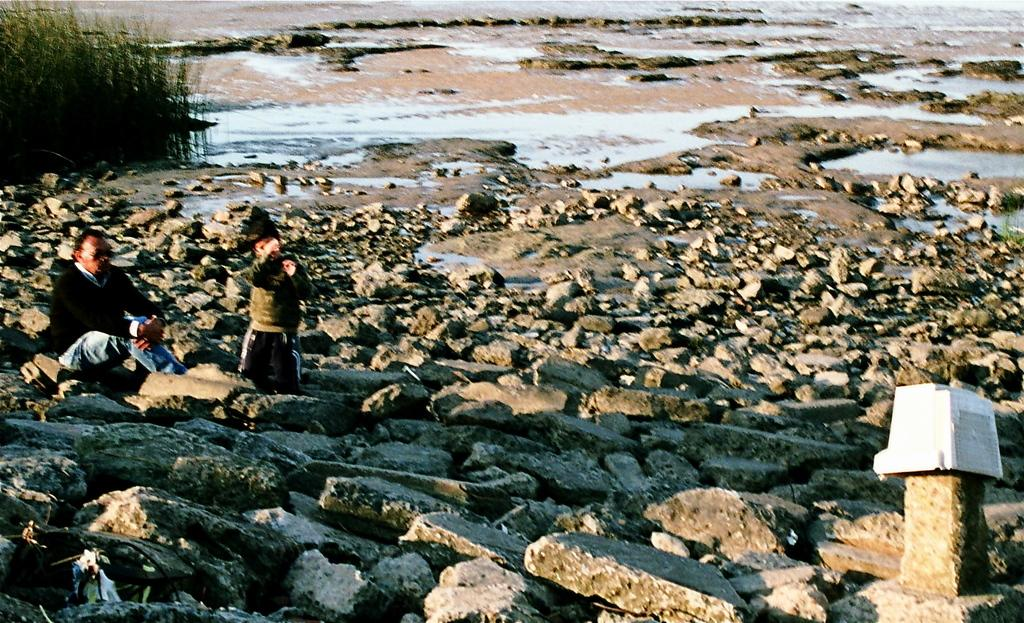How many people are present in the image? There are two persons in the image. What is visible in the image besides the people? Water and stones are visible in the image. What type of paper can be seen being destroyed in the image? There is no paper present in the image, nor is there any destruction taking place. 